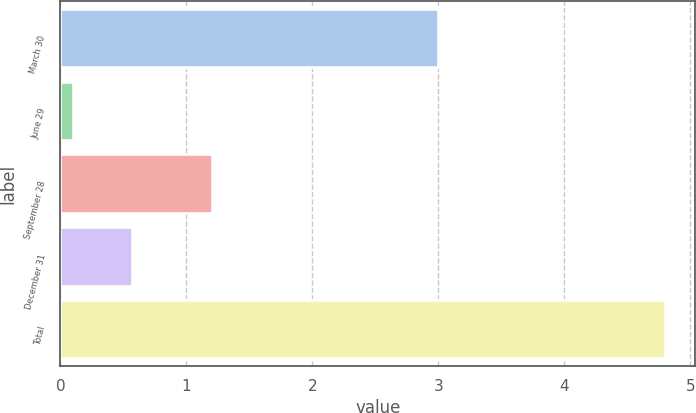Convert chart to OTSL. <chart><loc_0><loc_0><loc_500><loc_500><bar_chart><fcel>March 30<fcel>June 29<fcel>September 28<fcel>December 31<fcel>Total<nl><fcel>3<fcel>0.1<fcel>1.2<fcel>0.57<fcel>4.8<nl></chart> 